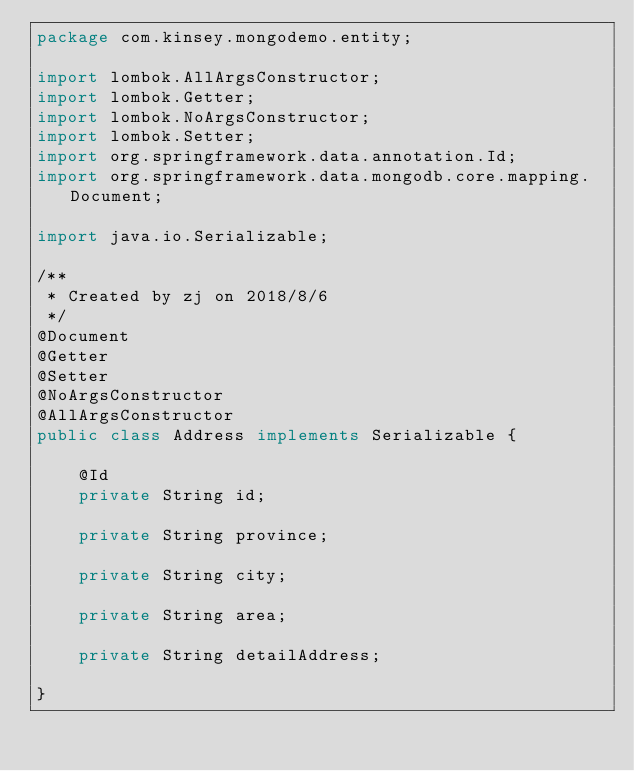<code> <loc_0><loc_0><loc_500><loc_500><_Java_>package com.kinsey.mongodemo.entity;

import lombok.AllArgsConstructor;
import lombok.Getter;
import lombok.NoArgsConstructor;
import lombok.Setter;
import org.springframework.data.annotation.Id;
import org.springframework.data.mongodb.core.mapping.Document;

import java.io.Serializable;

/**
 * Created by zj on 2018/8/6
 */
@Document
@Getter
@Setter
@NoArgsConstructor
@AllArgsConstructor
public class Address implements Serializable {

    @Id
    private String id;

    private String province;

    private String city;

    private String area;

    private String detailAddress;

}
</code> 